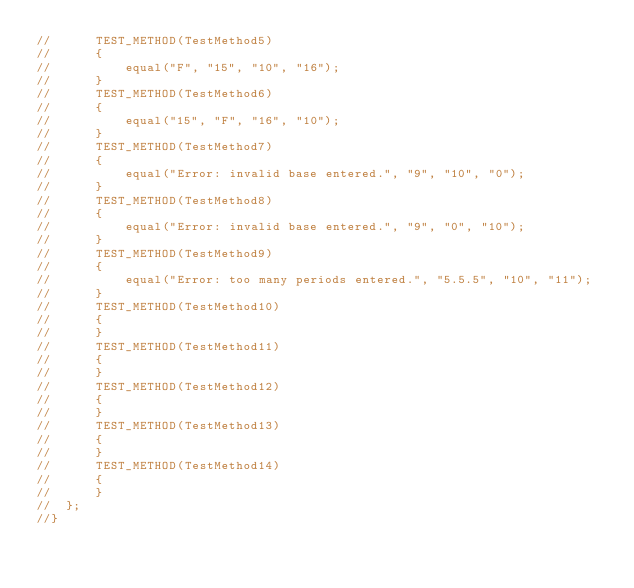<code> <loc_0><loc_0><loc_500><loc_500><_C++_>//		TEST_METHOD(TestMethod5)
//		{
//			equal("F", "15", "10", "16");
//		}
//		TEST_METHOD(TestMethod6)
//		{
//			equal("15", "F", "16", "10");
//		}
//		TEST_METHOD(TestMethod7)
//		{
//			equal("Error: invalid base entered.", "9", "10", "0");
//		}
//		TEST_METHOD(TestMethod8)
//		{
//			equal("Error: invalid base entered.", "9", "0", "10");
//		}
//		TEST_METHOD(TestMethod9)
//		{
//			equal("Error: too many periods entered.", "5.5.5", "10", "11");
//		}
//		TEST_METHOD(TestMethod10)
//		{
//		}
//		TEST_METHOD(TestMethod11)
//		{
//		}
//		TEST_METHOD(TestMethod12)
//		{
//		}
//		TEST_METHOD(TestMethod13)
//		{
//		}
//		TEST_METHOD(TestMethod14)
//		{
//		}
//	};
//}
</code> 